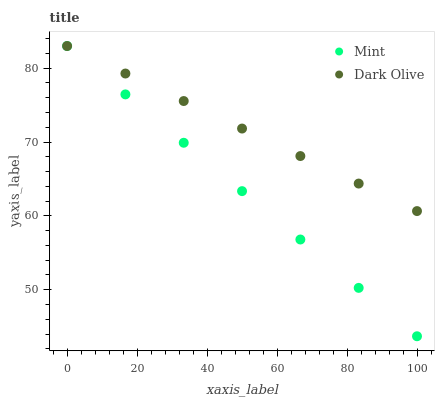Does Mint have the minimum area under the curve?
Answer yes or no. Yes. Does Dark Olive have the maximum area under the curve?
Answer yes or no. Yes. Does Mint have the maximum area under the curve?
Answer yes or no. No. Is Mint the smoothest?
Answer yes or no. Yes. Is Dark Olive the roughest?
Answer yes or no. Yes. Is Mint the roughest?
Answer yes or no. No. Does Mint have the lowest value?
Answer yes or no. Yes. Does Mint have the highest value?
Answer yes or no. Yes. Does Dark Olive intersect Mint?
Answer yes or no. Yes. Is Dark Olive less than Mint?
Answer yes or no. No. Is Dark Olive greater than Mint?
Answer yes or no. No. 